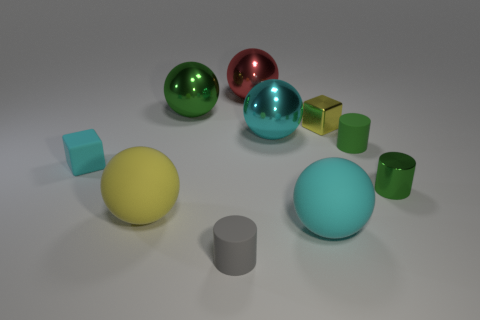Subtract 2 balls. How many balls are left? 3 Subtract all cylinders. How many objects are left? 7 Subtract 0 blue balls. How many objects are left? 10 Subtract all metal cubes. Subtract all tiny gray rubber cylinders. How many objects are left? 8 Add 4 gray rubber objects. How many gray rubber objects are left? 5 Add 2 small green rubber things. How many small green rubber things exist? 3 